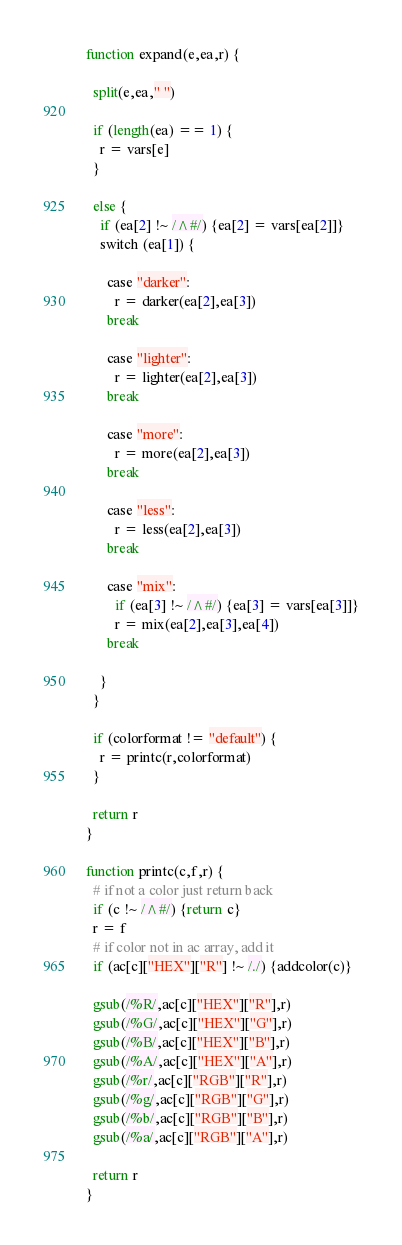Convert code to text. <code><loc_0><loc_0><loc_500><loc_500><_Awk_>
function expand(e,ea,r) {
  
  split(e,ea," ")

  if (length(ea) == 1) {
    r = vars[e]
  } 

  else {
    if (ea[2] !~ /^#/) {ea[2] = vars[ea[2]]}
    switch (ea[1]) {

      case "darker":
        r = darker(ea[2],ea[3])
      break

      case "lighter":
        r = lighter(ea[2],ea[3])
      break

      case "more":
        r = more(ea[2],ea[3])
      break

      case "less":
        r = less(ea[2],ea[3])
      break

      case "mix":
        if (ea[3] !~ /^#/) {ea[3] = vars[ea[3]]}
        r = mix(ea[2],ea[3],ea[4])
      break

    }
  }

  if (colorformat != "default") {
    r = printc(r,colorformat)
  }

  return r
}

function printc(c,f,r) {
  # if not a color just return back
  if (c !~ /^#/) {return c}
  r = f
  # if color not in ac array, add it
  if (ac[c]["HEX"]["R"] !~ /./) {addcolor(c)}

  gsub(/%R/,ac[c]["HEX"]["R"],r)
  gsub(/%G/,ac[c]["HEX"]["G"],r)
  gsub(/%B/,ac[c]["HEX"]["B"],r)
  gsub(/%A/,ac[c]["HEX"]["A"],r)
  gsub(/%r/,ac[c]["RGB"]["R"],r)
  gsub(/%g/,ac[c]["RGB"]["G"],r)
  gsub(/%b/,ac[c]["RGB"]["B"],r)
  gsub(/%a/,ac[c]["RGB"]["A"],r)

  return r
}
</code> 